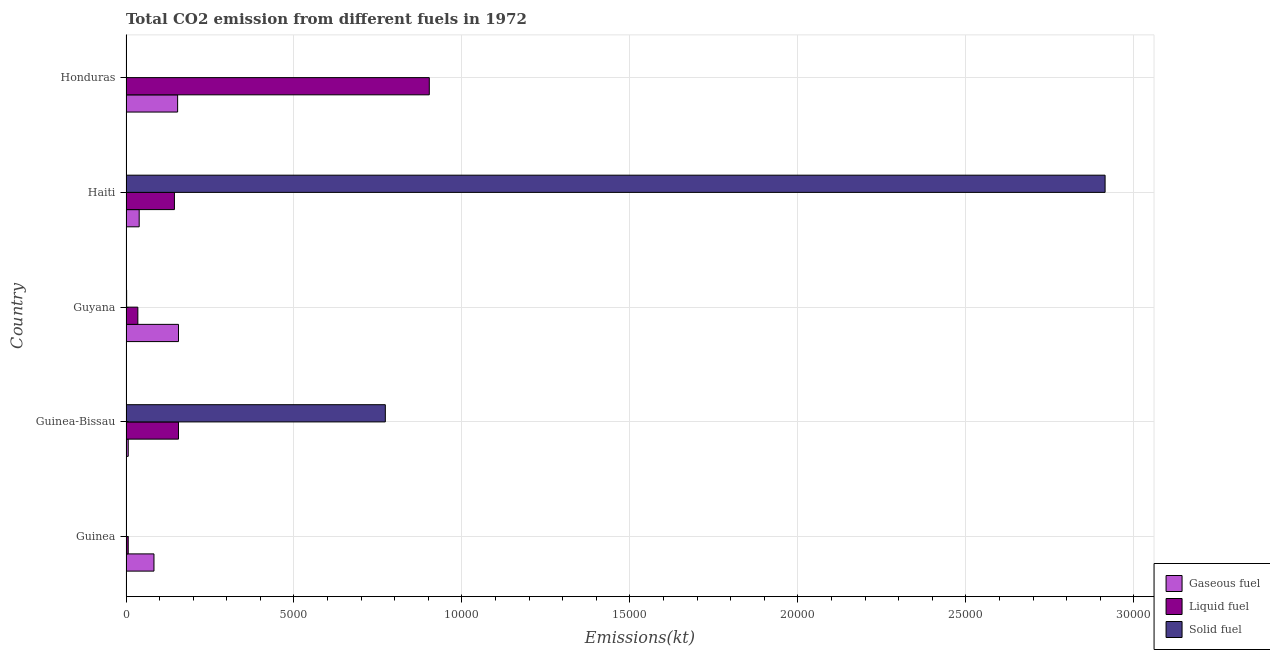How many different coloured bars are there?
Give a very brief answer. 3. How many groups of bars are there?
Your answer should be compact. 5. Are the number of bars per tick equal to the number of legend labels?
Your answer should be very brief. Yes. How many bars are there on the 1st tick from the bottom?
Ensure brevity in your answer.  3. What is the label of the 3rd group of bars from the top?
Make the answer very short. Guyana. In how many cases, is the number of bars for a given country not equal to the number of legend labels?
Ensure brevity in your answer.  0. What is the amount of co2 emissions from gaseous fuel in Guinea-Bissau?
Your answer should be compact. 66.01. Across all countries, what is the maximum amount of co2 emissions from gaseous fuel?
Your answer should be compact. 1562.14. Across all countries, what is the minimum amount of co2 emissions from gaseous fuel?
Keep it short and to the point. 66.01. In which country was the amount of co2 emissions from liquid fuel maximum?
Offer a terse response. Honduras. In which country was the amount of co2 emissions from liquid fuel minimum?
Make the answer very short. Guinea. What is the total amount of co2 emissions from solid fuel in the graph?
Make the answer very short. 3.69e+04. What is the difference between the amount of co2 emissions from gaseous fuel in Guinea-Bissau and that in Guyana?
Offer a terse response. -1496.14. What is the difference between the amount of co2 emissions from gaseous fuel in Guyana and the amount of co2 emissions from liquid fuel in Guinea-Bissau?
Your answer should be very brief. 0. What is the average amount of co2 emissions from gaseous fuel per country?
Make the answer very short. 877.88. What is the difference between the amount of co2 emissions from solid fuel and amount of co2 emissions from liquid fuel in Honduras?
Provide a succinct answer. -9024.49. What is the ratio of the amount of co2 emissions from liquid fuel in Guinea to that in Guyana?
Provide a succinct answer. 0.19. Is the amount of co2 emissions from liquid fuel in Guyana less than that in Haiti?
Ensure brevity in your answer.  Yes. Is the difference between the amount of co2 emissions from liquid fuel in Guinea and Guinea-Bissau greater than the difference between the amount of co2 emissions from gaseous fuel in Guinea and Guinea-Bissau?
Offer a terse response. No. What is the difference between the highest and the second highest amount of co2 emissions from solid fuel?
Keep it short and to the point. 2.14e+04. What is the difference between the highest and the lowest amount of co2 emissions from liquid fuel?
Keep it short and to the point. 8962.15. Is the sum of the amount of co2 emissions from liquid fuel in Guinea-Bissau and Honduras greater than the maximum amount of co2 emissions from gaseous fuel across all countries?
Offer a terse response. Yes. What does the 3rd bar from the top in Honduras represents?
Make the answer very short. Gaseous fuel. What does the 1st bar from the bottom in Honduras represents?
Make the answer very short. Gaseous fuel. Are all the bars in the graph horizontal?
Make the answer very short. Yes. What is the difference between two consecutive major ticks on the X-axis?
Ensure brevity in your answer.  5000. Does the graph contain any zero values?
Ensure brevity in your answer.  No. Does the graph contain grids?
Make the answer very short. Yes. What is the title of the graph?
Your answer should be compact. Total CO2 emission from different fuels in 1972. What is the label or title of the X-axis?
Provide a succinct answer. Emissions(kt). What is the Emissions(kt) of Gaseous fuel in Guinea?
Your answer should be very brief. 832.41. What is the Emissions(kt) of Liquid fuel in Guinea?
Provide a short and direct response. 66.01. What is the Emissions(kt) of Solid fuel in Guinea?
Your answer should be very brief. 7.33. What is the Emissions(kt) of Gaseous fuel in Guinea-Bissau?
Keep it short and to the point. 66.01. What is the Emissions(kt) of Liquid fuel in Guinea-Bissau?
Offer a terse response. 1562.14. What is the Emissions(kt) of Solid fuel in Guinea-Bissau?
Offer a terse response. 7719.03. What is the Emissions(kt) of Gaseous fuel in Guyana?
Keep it short and to the point. 1562.14. What is the Emissions(kt) in Liquid fuel in Guyana?
Give a very brief answer. 352.03. What is the Emissions(kt) of Solid fuel in Guyana?
Ensure brevity in your answer.  18.34. What is the Emissions(kt) of Gaseous fuel in Haiti?
Your answer should be compact. 392.37. What is the Emissions(kt) of Liquid fuel in Haiti?
Provide a succinct answer. 1441.13. What is the Emissions(kt) of Solid fuel in Haiti?
Ensure brevity in your answer.  2.91e+04. What is the Emissions(kt) in Gaseous fuel in Honduras?
Make the answer very short. 1536.47. What is the Emissions(kt) of Liquid fuel in Honduras?
Provide a short and direct response. 9028.15. What is the Emissions(kt) in Solid fuel in Honduras?
Give a very brief answer. 3.67. Across all countries, what is the maximum Emissions(kt) of Gaseous fuel?
Your answer should be very brief. 1562.14. Across all countries, what is the maximum Emissions(kt) in Liquid fuel?
Your response must be concise. 9028.15. Across all countries, what is the maximum Emissions(kt) of Solid fuel?
Give a very brief answer. 2.91e+04. Across all countries, what is the minimum Emissions(kt) in Gaseous fuel?
Your response must be concise. 66.01. Across all countries, what is the minimum Emissions(kt) in Liquid fuel?
Offer a terse response. 66.01. Across all countries, what is the minimum Emissions(kt) of Solid fuel?
Offer a very short reply. 3.67. What is the total Emissions(kt) of Gaseous fuel in the graph?
Your response must be concise. 4389.4. What is the total Emissions(kt) in Liquid fuel in the graph?
Offer a very short reply. 1.24e+04. What is the total Emissions(kt) of Solid fuel in the graph?
Offer a very short reply. 3.69e+04. What is the difference between the Emissions(kt) in Gaseous fuel in Guinea and that in Guinea-Bissau?
Provide a succinct answer. 766.4. What is the difference between the Emissions(kt) in Liquid fuel in Guinea and that in Guinea-Bissau?
Provide a short and direct response. -1496.14. What is the difference between the Emissions(kt) in Solid fuel in Guinea and that in Guinea-Bissau?
Offer a terse response. -7711.7. What is the difference between the Emissions(kt) in Gaseous fuel in Guinea and that in Guyana?
Give a very brief answer. -729.73. What is the difference between the Emissions(kt) of Liquid fuel in Guinea and that in Guyana?
Provide a short and direct response. -286.03. What is the difference between the Emissions(kt) in Solid fuel in Guinea and that in Guyana?
Keep it short and to the point. -11. What is the difference between the Emissions(kt) in Gaseous fuel in Guinea and that in Haiti?
Offer a very short reply. 440.04. What is the difference between the Emissions(kt) in Liquid fuel in Guinea and that in Haiti?
Provide a succinct answer. -1375.12. What is the difference between the Emissions(kt) in Solid fuel in Guinea and that in Haiti?
Your answer should be very brief. -2.91e+04. What is the difference between the Emissions(kt) in Gaseous fuel in Guinea and that in Honduras?
Offer a terse response. -704.06. What is the difference between the Emissions(kt) of Liquid fuel in Guinea and that in Honduras?
Offer a very short reply. -8962.15. What is the difference between the Emissions(kt) in Solid fuel in Guinea and that in Honduras?
Your answer should be very brief. 3.67. What is the difference between the Emissions(kt) of Gaseous fuel in Guinea-Bissau and that in Guyana?
Provide a succinct answer. -1496.14. What is the difference between the Emissions(kt) in Liquid fuel in Guinea-Bissau and that in Guyana?
Provide a short and direct response. 1210.11. What is the difference between the Emissions(kt) in Solid fuel in Guinea-Bissau and that in Guyana?
Give a very brief answer. 7700.7. What is the difference between the Emissions(kt) of Gaseous fuel in Guinea-Bissau and that in Haiti?
Offer a terse response. -326.36. What is the difference between the Emissions(kt) of Liquid fuel in Guinea-Bissau and that in Haiti?
Your response must be concise. 121.01. What is the difference between the Emissions(kt) of Solid fuel in Guinea-Bissau and that in Haiti?
Keep it short and to the point. -2.14e+04. What is the difference between the Emissions(kt) in Gaseous fuel in Guinea-Bissau and that in Honduras?
Your response must be concise. -1470.47. What is the difference between the Emissions(kt) in Liquid fuel in Guinea-Bissau and that in Honduras?
Keep it short and to the point. -7466.01. What is the difference between the Emissions(kt) in Solid fuel in Guinea-Bissau and that in Honduras?
Your response must be concise. 7715.37. What is the difference between the Emissions(kt) of Gaseous fuel in Guyana and that in Haiti?
Make the answer very short. 1169.77. What is the difference between the Emissions(kt) in Liquid fuel in Guyana and that in Haiti?
Ensure brevity in your answer.  -1089.1. What is the difference between the Emissions(kt) of Solid fuel in Guyana and that in Haiti?
Provide a short and direct response. -2.91e+04. What is the difference between the Emissions(kt) in Gaseous fuel in Guyana and that in Honduras?
Your response must be concise. 25.67. What is the difference between the Emissions(kt) of Liquid fuel in Guyana and that in Honduras?
Provide a short and direct response. -8676.12. What is the difference between the Emissions(kt) in Solid fuel in Guyana and that in Honduras?
Offer a terse response. 14.67. What is the difference between the Emissions(kt) in Gaseous fuel in Haiti and that in Honduras?
Keep it short and to the point. -1144.1. What is the difference between the Emissions(kt) of Liquid fuel in Haiti and that in Honduras?
Keep it short and to the point. -7587.02. What is the difference between the Emissions(kt) of Solid fuel in Haiti and that in Honduras?
Offer a very short reply. 2.91e+04. What is the difference between the Emissions(kt) in Gaseous fuel in Guinea and the Emissions(kt) in Liquid fuel in Guinea-Bissau?
Ensure brevity in your answer.  -729.73. What is the difference between the Emissions(kt) in Gaseous fuel in Guinea and the Emissions(kt) in Solid fuel in Guinea-Bissau?
Keep it short and to the point. -6886.63. What is the difference between the Emissions(kt) of Liquid fuel in Guinea and the Emissions(kt) of Solid fuel in Guinea-Bissau?
Offer a very short reply. -7653.03. What is the difference between the Emissions(kt) of Gaseous fuel in Guinea and the Emissions(kt) of Liquid fuel in Guyana?
Offer a very short reply. 480.38. What is the difference between the Emissions(kt) in Gaseous fuel in Guinea and the Emissions(kt) in Solid fuel in Guyana?
Your response must be concise. 814.07. What is the difference between the Emissions(kt) of Liquid fuel in Guinea and the Emissions(kt) of Solid fuel in Guyana?
Offer a very short reply. 47.67. What is the difference between the Emissions(kt) in Gaseous fuel in Guinea and the Emissions(kt) in Liquid fuel in Haiti?
Your answer should be very brief. -608.72. What is the difference between the Emissions(kt) of Gaseous fuel in Guinea and the Emissions(kt) of Solid fuel in Haiti?
Your answer should be very brief. -2.83e+04. What is the difference between the Emissions(kt) in Liquid fuel in Guinea and the Emissions(kt) in Solid fuel in Haiti?
Your response must be concise. -2.91e+04. What is the difference between the Emissions(kt) of Gaseous fuel in Guinea and the Emissions(kt) of Liquid fuel in Honduras?
Provide a succinct answer. -8195.75. What is the difference between the Emissions(kt) of Gaseous fuel in Guinea and the Emissions(kt) of Solid fuel in Honduras?
Offer a terse response. 828.74. What is the difference between the Emissions(kt) in Liquid fuel in Guinea and the Emissions(kt) in Solid fuel in Honduras?
Give a very brief answer. 62.34. What is the difference between the Emissions(kt) of Gaseous fuel in Guinea-Bissau and the Emissions(kt) of Liquid fuel in Guyana?
Give a very brief answer. -286.03. What is the difference between the Emissions(kt) of Gaseous fuel in Guinea-Bissau and the Emissions(kt) of Solid fuel in Guyana?
Give a very brief answer. 47.67. What is the difference between the Emissions(kt) in Liquid fuel in Guinea-Bissau and the Emissions(kt) in Solid fuel in Guyana?
Give a very brief answer. 1543.81. What is the difference between the Emissions(kt) of Gaseous fuel in Guinea-Bissau and the Emissions(kt) of Liquid fuel in Haiti?
Provide a short and direct response. -1375.12. What is the difference between the Emissions(kt) of Gaseous fuel in Guinea-Bissau and the Emissions(kt) of Solid fuel in Haiti?
Offer a very short reply. -2.91e+04. What is the difference between the Emissions(kt) in Liquid fuel in Guinea-Bissau and the Emissions(kt) in Solid fuel in Haiti?
Make the answer very short. -2.76e+04. What is the difference between the Emissions(kt) of Gaseous fuel in Guinea-Bissau and the Emissions(kt) of Liquid fuel in Honduras?
Ensure brevity in your answer.  -8962.15. What is the difference between the Emissions(kt) in Gaseous fuel in Guinea-Bissau and the Emissions(kt) in Solid fuel in Honduras?
Ensure brevity in your answer.  62.34. What is the difference between the Emissions(kt) in Liquid fuel in Guinea-Bissau and the Emissions(kt) in Solid fuel in Honduras?
Keep it short and to the point. 1558.47. What is the difference between the Emissions(kt) of Gaseous fuel in Guyana and the Emissions(kt) of Liquid fuel in Haiti?
Give a very brief answer. 121.01. What is the difference between the Emissions(kt) in Gaseous fuel in Guyana and the Emissions(kt) in Solid fuel in Haiti?
Your answer should be compact. -2.76e+04. What is the difference between the Emissions(kt) of Liquid fuel in Guyana and the Emissions(kt) of Solid fuel in Haiti?
Give a very brief answer. -2.88e+04. What is the difference between the Emissions(kt) of Gaseous fuel in Guyana and the Emissions(kt) of Liquid fuel in Honduras?
Make the answer very short. -7466.01. What is the difference between the Emissions(kt) of Gaseous fuel in Guyana and the Emissions(kt) of Solid fuel in Honduras?
Ensure brevity in your answer.  1558.47. What is the difference between the Emissions(kt) in Liquid fuel in Guyana and the Emissions(kt) in Solid fuel in Honduras?
Your answer should be compact. 348.37. What is the difference between the Emissions(kt) of Gaseous fuel in Haiti and the Emissions(kt) of Liquid fuel in Honduras?
Your answer should be very brief. -8635.78. What is the difference between the Emissions(kt) in Gaseous fuel in Haiti and the Emissions(kt) in Solid fuel in Honduras?
Ensure brevity in your answer.  388.7. What is the difference between the Emissions(kt) in Liquid fuel in Haiti and the Emissions(kt) in Solid fuel in Honduras?
Your answer should be very brief. 1437.46. What is the average Emissions(kt) of Gaseous fuel per country?
Make the answer very short. 877.88. What is the average Emissions(kt) of Liquid fuel per country?
Ensure brevity in your answer.  2489.89. What is the average Emissions(kt) in Solid fuel per country?
Make the answer very short. 7378.74. What is the difference between the Emissions(kt) in Gaseous fuel and Emissions(kt) in Liquid fuel in Guinea?
Your answer should be very brief. 766.4. What is the difference between the Emissions(kt) of Gaseous fuel and Emissions(kt) of Solid fuel in Guinea?
Keep it short and to the point. 825.08. What is the difference between the Emissions(kt) of Liquid fuel and Emissions(kt) of Solid fuel in Guinea?
Give a very brief answer. 58.67. What is the difference between the Emissions(kt) in Gaseous fuel and Emissions(kt) in Liquid fuel in Guinea-Bissau?
Keep it short and to the point. -1496.14. What is the difference between the Emissions(kt) in Gaseous fuel and Emissions(kt) in Solid fuel in Guinea-Bissau?
Keep it short and to the point. -7653.03. What is the difference between the Emissions(kt) of Liquid fuel and Emissions(kt) of Solid fuel in Guinea-Bissau?
Make the answer very short. -6156.89. What is the difference between the Emissions(kt) of Gaseous fuel and Emissions(kt) of Liquid fuel in Guyana?
Give a very brief answer. 1210.11. What is the difference between the Emissions(kt) in Gaseous fuel and Emissions(kt) in Solid fuel in Guyana?
Make the answer very short. 1543.81. What is the difference between the Emissions(kt) in Liquid fuel and Emissions(kt) in Solid fuel in Guyana?
Your response must be concise. 333.7. What is the difference between the Emissions(kt) of Gaseous fuel and Emissions(kt) of Liquid fuel in Haiti?
Your answer should be very brief. -1048.76. What is the difference between the Emissions(kt) in Gaseous fuel and Emissions(kt) in Solid fuel in Haiti?
Keep it short and to the point. -2.88e+04. What is the difference between the Emissions(kt) of Liquid fuel and Emissions(kt) of Solid fuel in Haiti?
Offer a terse response. -2.77e+04. What is the difference between the Emissions(kt) in Gaseous fuel and Emissions(kt) in Liquid fuel in Honduras?
Give a very brief answer. -7491.68. What is the difference between the Emissions(kt) of Gaseous fuel and Emissions(kt) of Solid fuel in Honduras?
Your answer should be compact. 1532.81. What is the difference between the Emissions(kt) in Liquid fuel and Emissions(kt) in Solid fuel in Honduras?
Your response must be concise. 9024.49. What is the ratio of the Emissions(kt) of Gaseous fuel in Guinea to that in Guinea-Bissau?
Ensure brevity in your answer.  12.61. What is the ratio of the Emissions(kt) in Liquid fuel in Guinea to that in Guinea-Bissau?
Your response must be concise. 0.04. What is the ratio of the Emissions(kt) in Solid fuel in Guinea to that in Guinea-Bissau?
Offer a very short reply. 0. What is the ratio of the Emissions(kt) of Gaseous fuel in Guinea to that in Guyana?
Your answer should be compact. 0.53. What is the ratio of the Emissions(kt) in Liquid fuel in Guinea to that in Guyana?
Your answer should be very brief. 0.19. What is the ratio of the Emissions(kt) of Solid fuel in Guinea to that in Guyana?
Provide a succinct answer. 0.4. What is the ratio of the Emissions(kt) of Gaseous fuel in Guinea to that in Haiti?
Your answer should be very brief. 2.12. What is the ratio of the Emissions(kt) of Liquid fuel in Guinea to that in Haiti?
Provide a short and direct response. 0.05. What is the ratio of the Emissions(kt) of Gaseous fuel in Guinea to that in Honduras?
Make the answer very short. 0.54. What is the ratio of the Emissions(kt) of Liquid fuel in Guinea to that in Honduras?
Your response must be concise. 0.01. What is the ratio of the Emissions(kt) of Solid fuel in Guinea to that in Honduras?
Offer a terse response. 2. What is the ratio of the Emissions(kt) in Gaseous fuel in Guinea-Bissau to that in Guyana?
Your answer should be compact. 0.04. What is the ratio of the Emissions(kt) of Liquid fuel in Guinea-Bissau to that in Guyana?
Your answer should be compact. 4.44. What is the ratio of the Emissions(kt) in Solid fuel in Guinea-Bissau to that in Guyana?
Offer a terse response. 421. What is the ratio of the Emissions(kt) in Gaseous fuel in Guinea-Bissau to that in Haiti?
Ensure brevity in your answer.  0.17. What is the ratio of the Emissions(kt) in Liquid fuel in Guinea-Bissau to that in Haiti?
Offer a terse response. 1.08. What is the ratio of the Emissions(kt) in Solid fuel in Guinea-Bissau to that in Haiti?
Give a very brief answer. 0.26. What is the ratio of the Emissions(kt) in Gaseous fuel in Guinea-Bissau to that in Honduras?
Your response must be concise. 0.04. What is the ratio of the Emissions(kt) in Liquid fuel in Guinea-Bissau to that in Honduras?
Your answer should be very brief. 0.17. What is the ratio of the Emissions(kt) in Solid fuel in Guinea-Bissau to that in Honduras?
Your answer should be compact. 2105. What is the ratio of the Emissions(kt) in Gaseous fuel in Guyana to that in Haiti?
Offer a terse response. 3.98. What is the ratio of the Emissions(kt) in Liquid fuel in Guyana to that in Haiti?
Your answer should be very brief. 0.24. What is the ratio of the Emissions(kt) in Solid fuel in Guyana to that in Haiti?
Offer a very short reply. 0. What is the ratio of the Emissions(kt) of Gaseous fuel in Guyana to that in Honduras?
Your answer should be very brief. 1.02. What is the ratio of the Emissions(kt) of Liquid fuel in Guyana to that in Honduras?
Make the answer very short. 0.04. What is the ratio of the Emissions(kt) of Gaseous fuel in Haiti to that in Honduras?
Your answer should be very brief. 0.26. What is the ratio of the Emissions(kt) in Liquid fuel in Haiti to that in Honduras?
Ensure brevity in your answer.  0.16. What is the ratio of the Emissions(kt) of Solid fuel in Haiti to that in Honduras?
Give a very brief answer. 7948. What is the difference between the highest and the second highest Emissions(kt) of Gaseous fuel?
Offer a very short reply. 25.67. What is the difference between the highest and the second highest Emissions(kt) of Liquid fuel?
Provide a short and direct response. 7466.01. What is the difference between the highest and the second highest Emissions(kt) in Solid fuel?
Ensure brevity in your answer.  2.14e+04. What is the difference between the highest and the lowest Emissions(kt) of Gaseous fuel?
Offer a terse response. 1496.14. What is the difference between the highest and the lowest Emissions(kt) in Liquid fuel?
Provide a short and direct response. 8962.15. What is the difference between the highest and the lowest Emissions(kt) in Solid fuel?
Provide a short and direct response. 2.91e+04. 